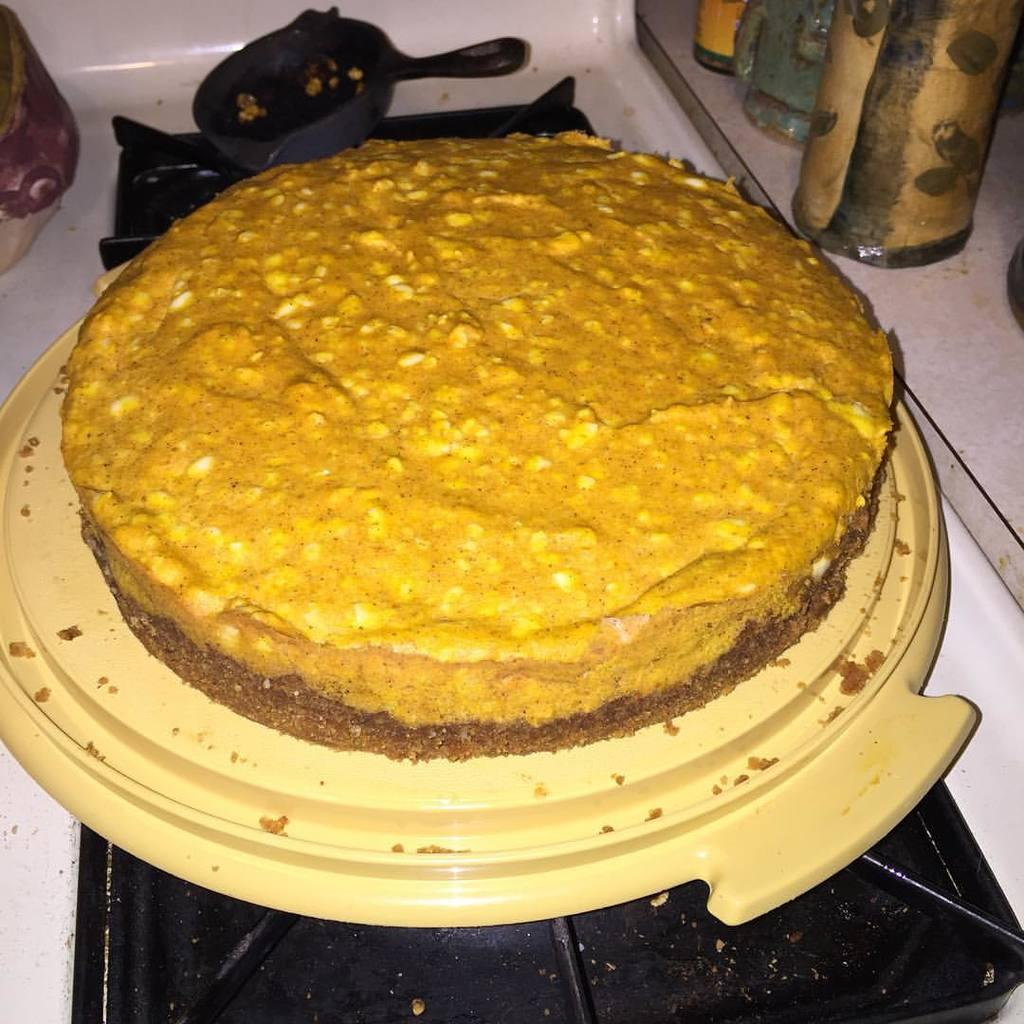What is the main food item visible in the image? There is a cake on a plate in the image. What is located near the stove in the image? There is a container on the stove in the image. What can be seen in the background of the image? There are bottles visible in the background of the image. How many dogs are playing in the bushes in the image? There are no dogs or bushes present in the image. 